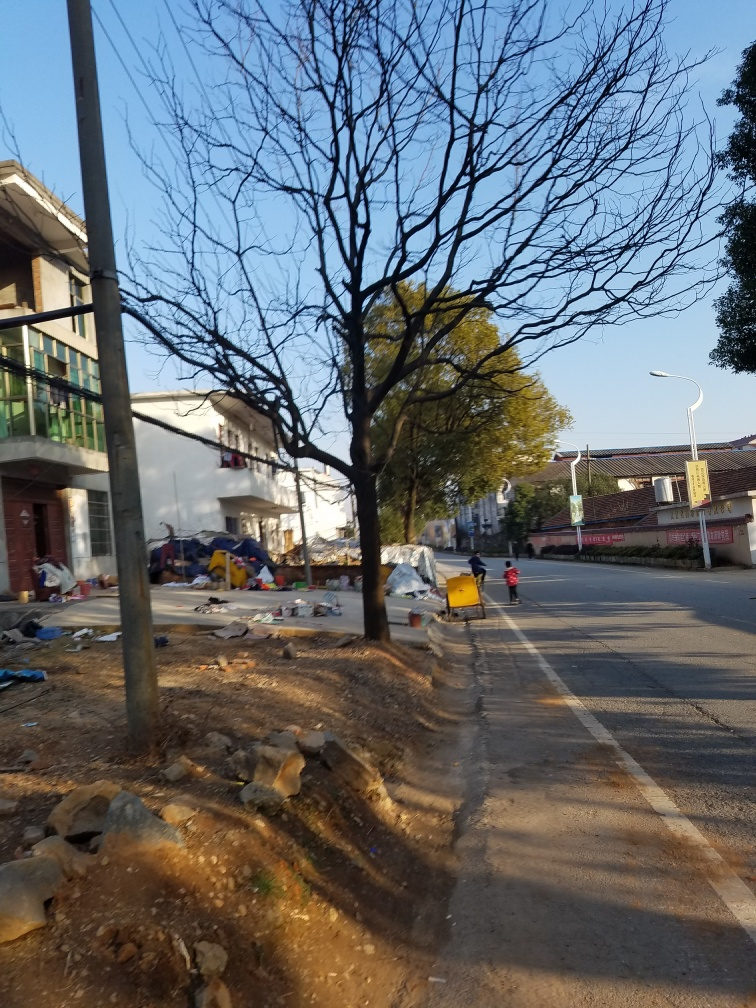What does the presence of the child on the scooter contribute to the scene? The presence of the child on the scooter adds a sense of everyday life and activity to the scene. It creates a contrast between the liveliness of human activity and the somewhat neglected condition of the street environment, underscoring a narrative of resilience or adaptation. Is there anything in the image that suggests the location or the country where this might be? While there are no explicit indicators of the exact location, the style of the buildings, the roadside infrastructure, and the visible signage could suggest that this is a semi-urban area in a country with warm climates, potentially in a developing or emerging economy region. 